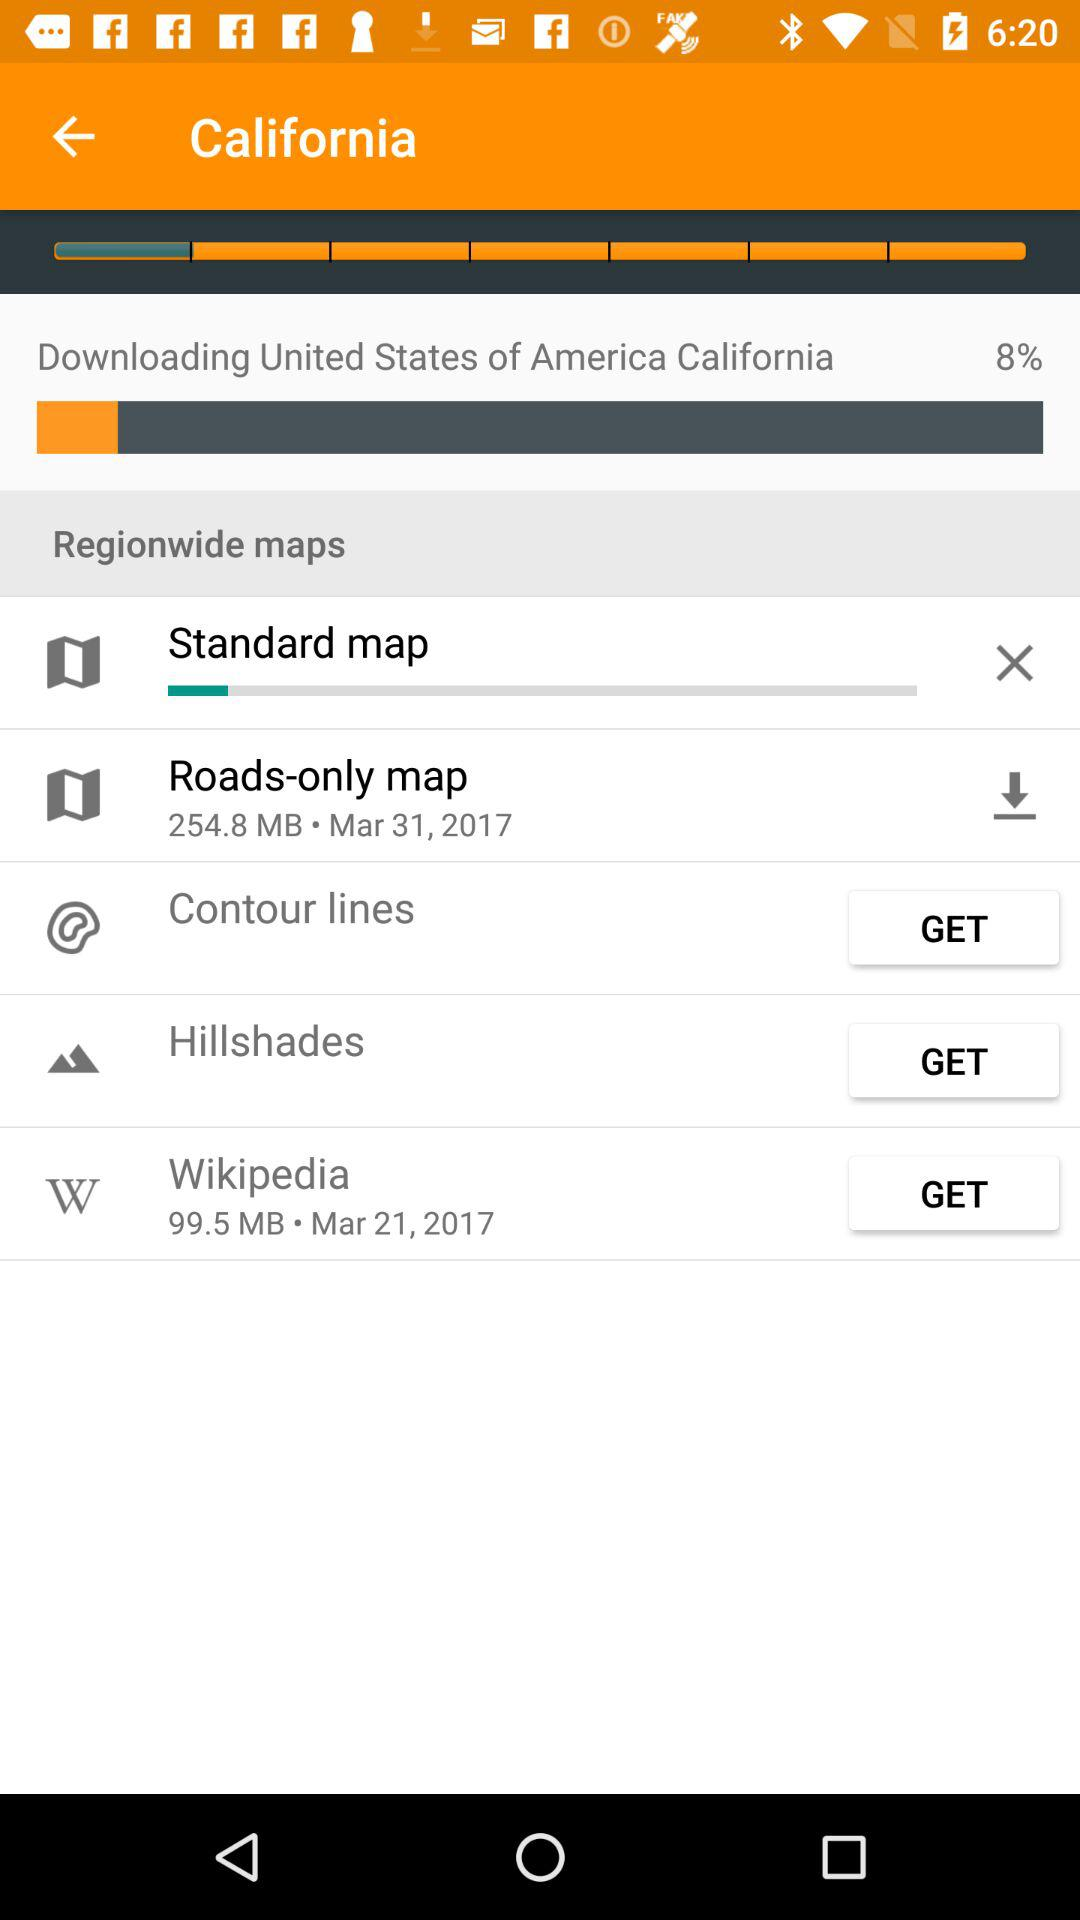What is the size (in megabytes) of "Roads-only map"? The size (in megabytes) of "Roads-only map" is 254.8. 